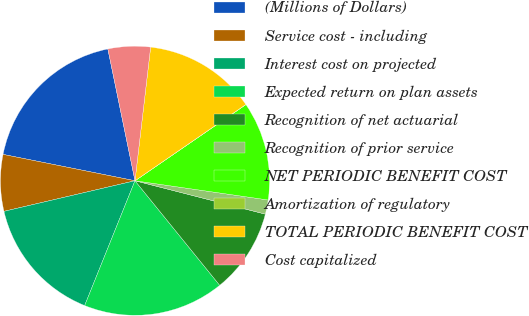Convert chart. <chart><loc_0><loc_0><loc_500><loc_500><pie_chart><fcel>(Millions of Dollars)<fcel>Service cost - including<fcel>Interest cost on projected<fcel>Expected return on plan assets<fcel>Recognition of net actuarial<fcel>Recognition of prior service<fcel>NET PERIODIC BENEFIT COST<fcel>Amortization of regulatory<fcel>TOTAL PERIODIC BENEFIT COST<fcel>Cost capitalized<nl><fcel>18.63%<fcel>6.79%<fcel>15.25%<fcel>16.94%<fcel>10.17%<fcel>1.71%<fcel>11.86%<fcel>0.02%<fcel>13.55%<fcel>5.09%<nl></chart> 